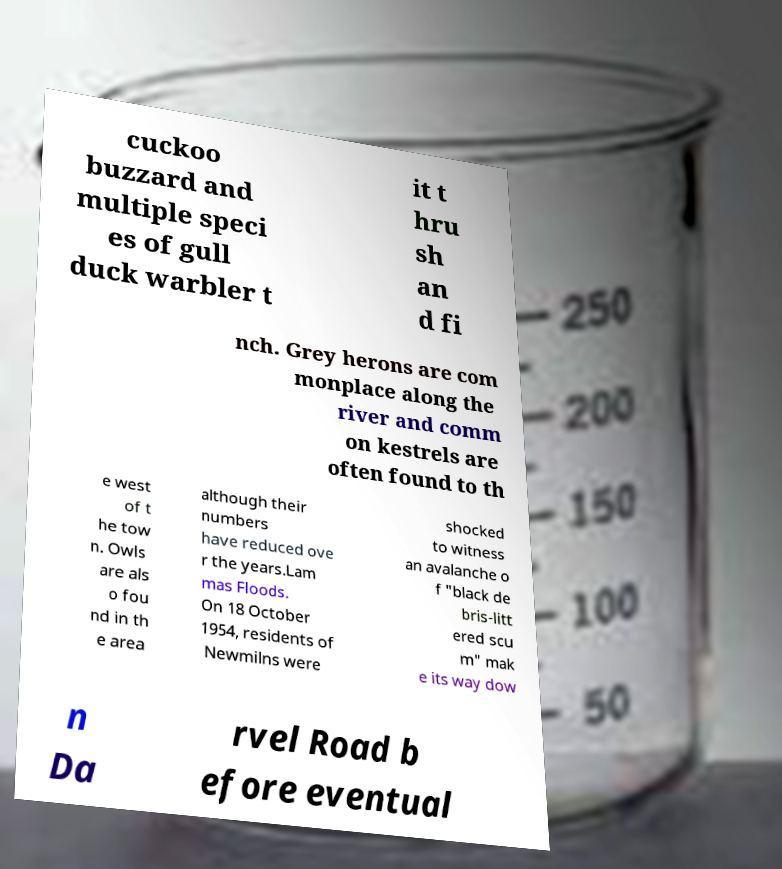Please read and relay the text visible in this image. What does it say? cuckoo buzzard and multiple speci es of gull duck warbler t it t hru sh an d fi nch. Grey herons are com monplace along the river and comm on kestrels are often found to th e west of t he tow n. Owls are als o fou nd in th e area although their numbers have reduced ove r the years.Lam mas Floods. On 18 October 1954, residents of Newmilns were shocked to witness an avalanche o f "black de bris-litt ered scu m" mak e its way dow n Da rvel Road b efore eventual 